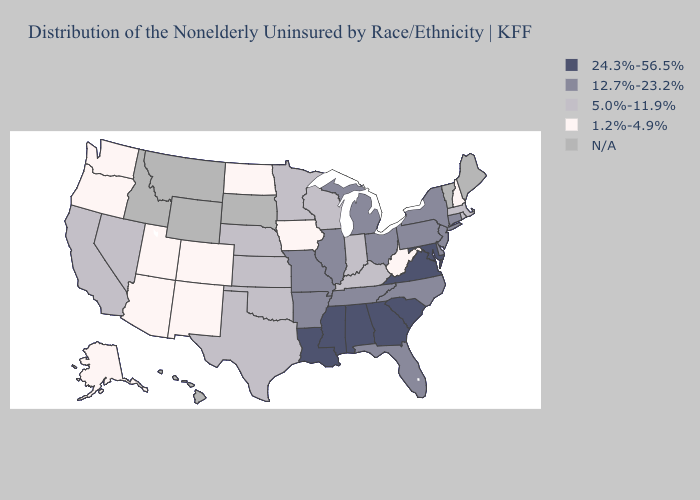Does New Hampshire have the lowest value in the USA?
Keep it brief. Yes. What is the lowest value in the Northeast?
Answer briefly. 1.2%-4.9%. Name the states that have a value in the range 12.7%-23.2%?
Answer briefly. Arkansas, Connecticut, Delaware, Florida, Illinois, Michigan, Missouri, New Jersey, New York, North Carolina, Ohio, Pennsylvania, Tennessee. Name the states that have a value in the range 1.2%-4.9%?
Short answer required. Alaska, Arizona, Colorado, Iowa, New Hampshire, New Mexico, North Dakota, Oregon, Utah, Washington, West Virginia. Name the states that have a value in the range 5.0%-11.9%?
Give a very brief answer. California, Indiana, Kansas, Kentucky, Massachusetts, Minnesota, Nebraska, Nevada, Oklahoma, Rhode Island, Texas, Wisconsin. What is the highest value in the USA?
Quick response, please. 24.3%-56.5%. Is the legend a continuous bar?
Be succinct. No. What is the value of Illinois?
Quick response, please. 12.7%-23.2%. Name the states that have a value in the range 1.2%-4.9%?
Be succinct. Alaska, Arizona, Colorado, Iowa, New Hampshire, New Mexico, North Dakota, Oregon, Utah, Washington, West Virginia. Which states have the lowest value in the USA?
Write a very short answer. Alaska, Arizona, Colorado, Iowa, New Hampshire, New Mexico, North Dakota, Oregon, Utah, Washington, West Virginia. What is the value of New York?
Short answer required. 12.7%-23.2%. What is the lowest value in the USA?
Short answer required. 1.2%-4.9%. What is the value of California?
Concise answer only. 5.0%-11.9%. What is the highest value in the MidWest ?
Quick response, please. 12.7%-23.2%. Which states have the lowest value in the Northeast?
Quick response, please. New Hampshire. 